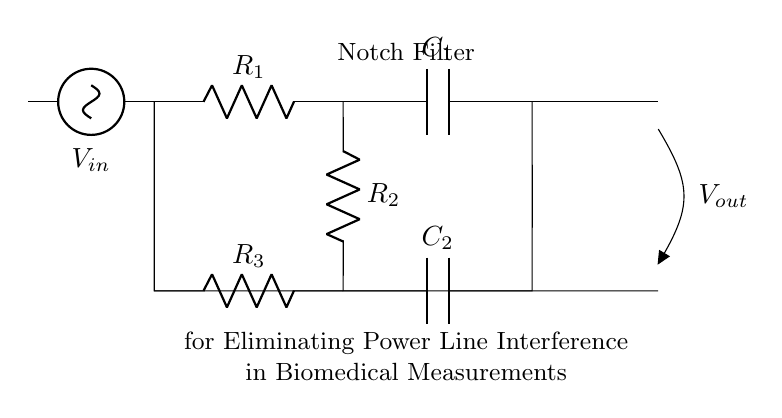What is the component type of R1? R1 is listed as a resistor in the circuit diagram.
Answer: Resistor What is the value of the capacitor connected to R2? C2 is labeled as a capacitor in the circuit; specific values are not provided in the diagram.
Answer: Capacitor How many resistors are in this notch filter circuit? The diagram shows three resistors: R1, R2, and R3.
Answer: Three What is the role of the capacitors in the notch filter? The capacitors are used to determine the frequency response of the notch filter, specifically helping to eliminate the power line interference.
Answer: Eliminate interference What is the overall function of this circuit? This circuit is designed as a notch filter to reduce or eliminate power line interference present in biomedical measurements, allowing for clearer signal analysis.
Answer: Notch filter Which voltage source is connected to the circuit? The circuit shows a voltage source labeled as V_in connected at the input.
Answer: V_in Which components are connected in parallel in this circuit? R2 and C2 are connected in parallel with R3 and the rest of the circuit; they share the same voltage across them.
Answer: R2 and C2 